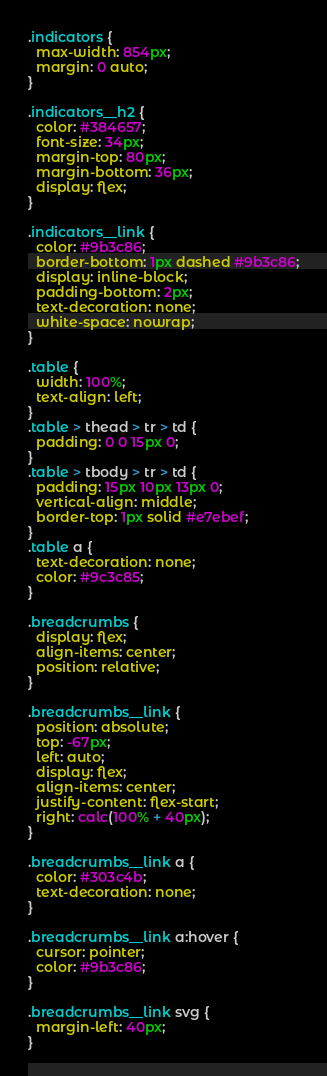<code> <loc_0><loc_0><loc_500><loc_500><_CSS_>.indicators {
  max-width: 854px;
  margin: 0 auto;
}

.indicators__h2 {
  color: #384657;
  font-size: 34px;
  margin-top: 80px;
  margin-bottom: 36px;
  display: flex;
}

.indicators__link {
  color: #9b3c86;
  border-bottom: 1px dashed #9b3c86;
  display: inline-block;
  padding-bottom: 2px;
  text-decoration: none;
  white-space: nowrap;
}

.table {
  width: 100%;
  text-align: left;
}
.table > thead > tr > td {
  padding: 0 0 15px 0;
}
.table > tbody > tr > td {
  padding: 15px 10px 13px 0;
  vertical-align: middle;
  border-top: 1px solid #e7ebef;
}
.table a {
  text-decoration: none;
  color: #9c3c85;
}

.breadcrumbs {
  display: flex;
  align-items: center;
  position: relative;
}

.breadcrumbs__link {
  position: absolute;
  top: -67px;
  left: auto;
  display: flex;
  align-items: center;
  justify-content: flex-start;
  right: calc(100% + 40px);
}

.breadcrumbs__link a {
  color: #303c4b;
  text-decoration: none;
}

.breadcrumbs__link a:hover {
  cursor: pointer;
  color: #9b3c86;
}

.breadcrumbs__link svg {
  margin-left: 40px;
}
</code> 